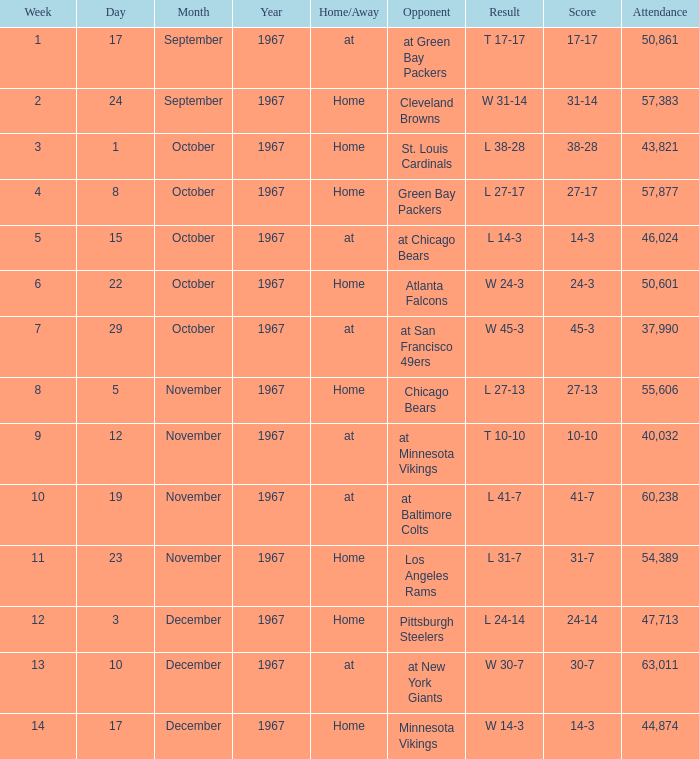Which Date has a Week smaller than 8, and an Opponent of atlanta falcons? October 22, 1967. 